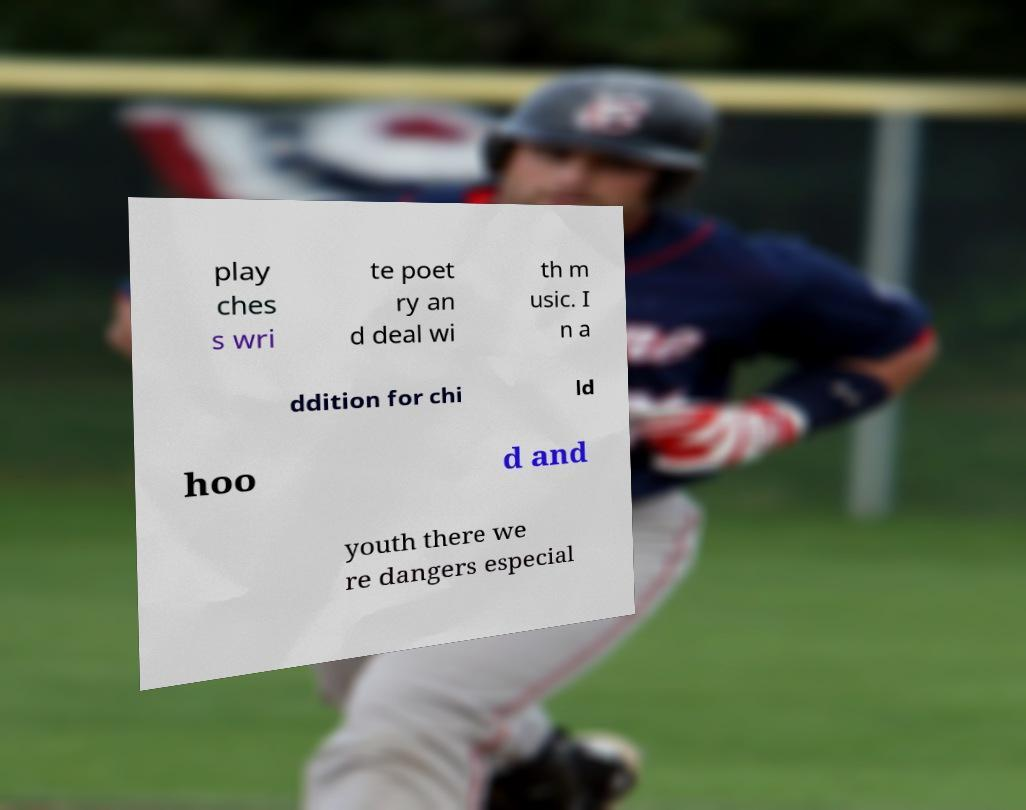Could you extract and type out the text from this image? play ches s wri te poet ry an d deal wi th m usic. I n a ddition for chi ld hoo d and youth there we re dangers especial 